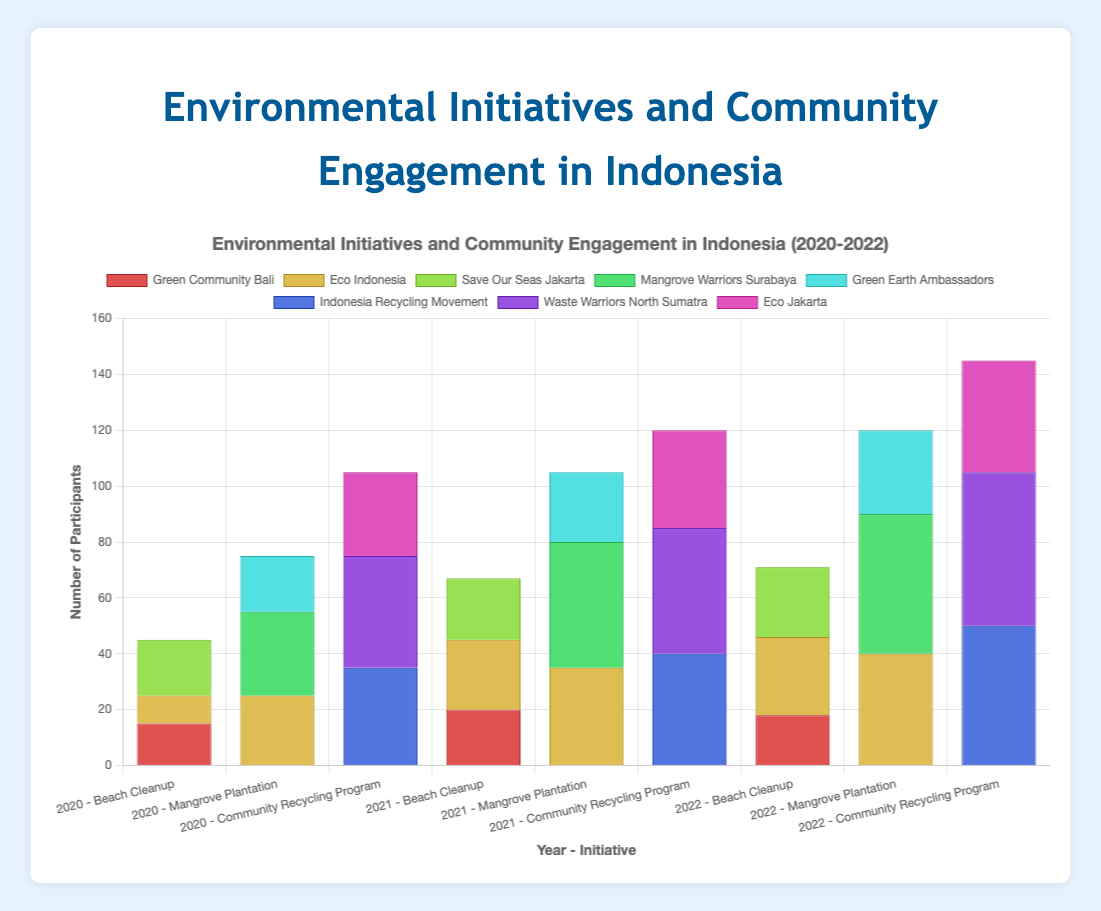Which organization participated the most in the 2020 Beach Cleanup? Look at the bars related to the 2020 Beach Cleanup. The highest bar represents Save Our Seas Jakarta with 20 participants.
Answer: Save Our Seas Jakarta What is the total number of participants for the 2022 Community Recycling Program? Sum the number of participants from all organizations involved in 2022 Community Recycling Program: Indonesia Recycling Movement (50) + Waste Warriors North Sumatra (55) + Eco Jakarta (40) = 145.
Answer: 145 Which initiative saw the highest increase in participants from 2020 to 2021 by Eco Indonesia? Compare the participants of Eco Indonesia across initiatives from 2020 to 2021. For Beach Cleanup: 10 to 25 (increase of 15), Mangrove Plantation: 25 to 35 (increase of 10), Community Recycling Program: 0 to 0 (no change). The highest increase was in Beach Cleanup.
Answer: Beach Cleanup In 2022, which organization had the lowest participation in the Beach Cleanup initiative? Look at the figure for the Beach Cleanup initiative in 2022. The shortest bar represents Green Community Bali with 18 participants.
Answer: Green Community Bali What is the average number of participants per year for Mangrove Warriors Surabaya in the Mangrove Plantation initiative from 2020 to 2022? Sum the participants for each year: 30 (2020) + 45 (2021) + 50 (2022) = 125. Divide by the number of years (3) to find the average: 125 / 3 ≈ 41.67.
Answer: 41.67 How did the number of participants in the Beach Cleanup initiative for Green Community Bali change from 2020 to 2022? Check the figure for Beach Cleanup initiative by Green Community Bali over the years: 15 (2020), 20 (2021), 18 (2022). It increased from 2020 to 2021 by 5, then decreased from 2021 to 2022 by 2.
Answer: Increased by 5 (2020-2021), decreased by 2 (2021-2022) Which initiative and year combination had the highest total number of participants? Sum the participants for each initiative-year combination and identify the highest. Community Recycling Program in 2022 has Indonesia Recycling Movement (50) + Waste Warriors North Sumatra (55) + Eco Jakarta (40) = 145, which is the highest.
Answer: Community Recycling Program in 2022 In 2021, which organization saw the highest participation in Community Recycling Program? Check the 2021 bars for Community Recycling Program. The tallest bar represents Waste Warriors North Sumatra with 45 participants.
Answer: Waste Warriors North Sumatra Compare the participation of Eco Indonesia in the Beach Cleanup and Mangrove Plantation initiatives in 2022. Which one had more participants? In 2022, Eco Indonesia had 28 participants in Beach Cleanup and 40 participants in Mangrove Plantation. Mangrove Plantation had more participants.
Answer: Mangrove Plantation What is the combined total number of participants for Eco Indonesia across all initiatives in 2021? Add the number of participants for Eco Indonesia across all initiatives in 2021: Beach Cleanup (25) + Mangrove Plantation (35) + Community Recycling Program (0) = 60.
Answer: 60 